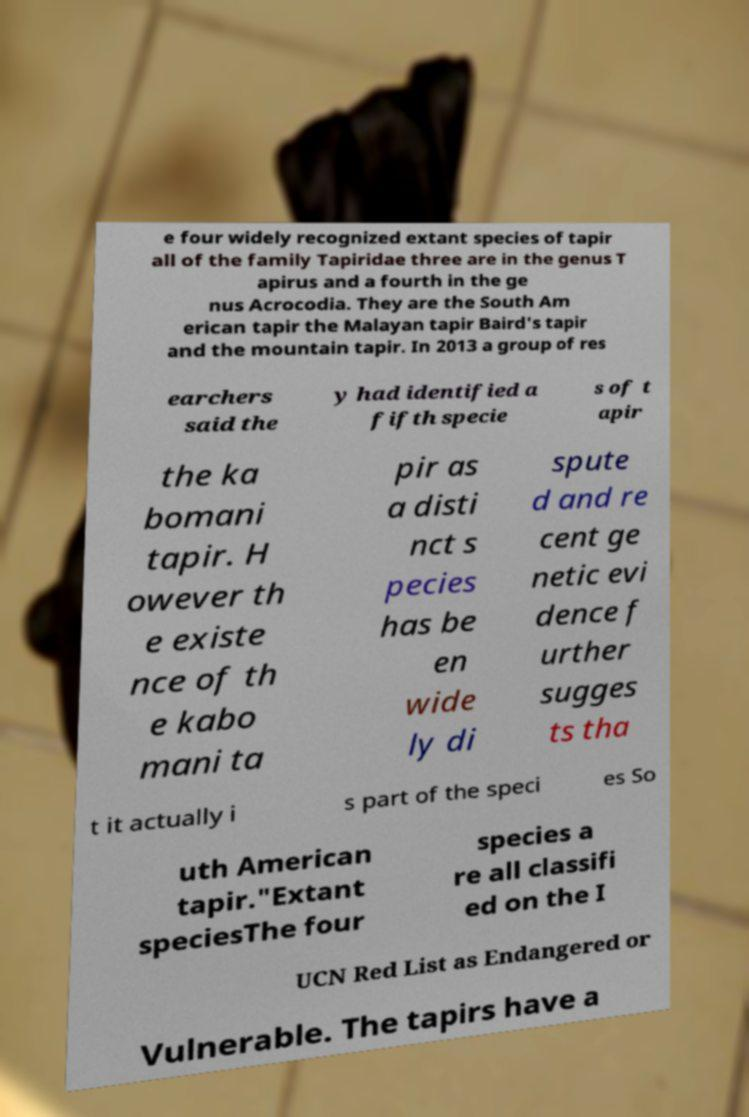Can you read and provide the text displayed in the image?This photo seems to have some interesting text. Can you extract and type it out for me? e four widely recognized extant species of tapir all of the family Tapiridae three are in the genus T apirus and a fourth in the ge nus Acrocodia. They are the South Am erican tapir the Malayan tapir Baird's tapir and the mountain tapir. In 2013 a group of res earchers said the y had identified a fifth specie s of t apir the ka bomani tapir. H owever th e existe nce of th e kabo mani ta pir as a disti nct s pecies has be en wide ly di spute d and re cent ge netic evi dence f urther sugges ts tha t it actually i s part of the speci es So uth American tapir."Extant speciesThe four species a re all classifi ed on the I UCN Red List as Endangered or Vulnerable. The tapirs have a 